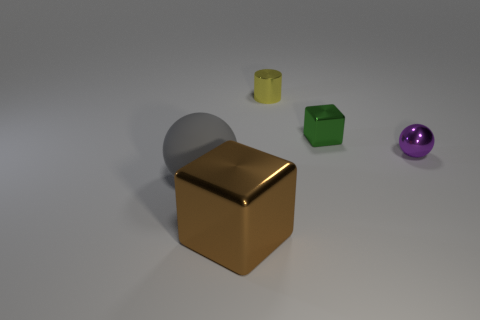How do the light and shadows in the image help us understand the shapes and textures of the objects? The image has been carefully lit to accentuate the textures and forms of each object. Soft shadows gently outline the bases of the objects, grounding them in the space, and highlighting the three-dimensionality of the shapes. The light reflects differently on each object's surface: matte surfaces like the gray sphere and green cube scatter the light softly, while the glossy surfaces of the gold cube and purple sphere catch and mirror the light sharply. This contrast helps to showcase their unique material properties and enhances the perception of depth and solidity. 